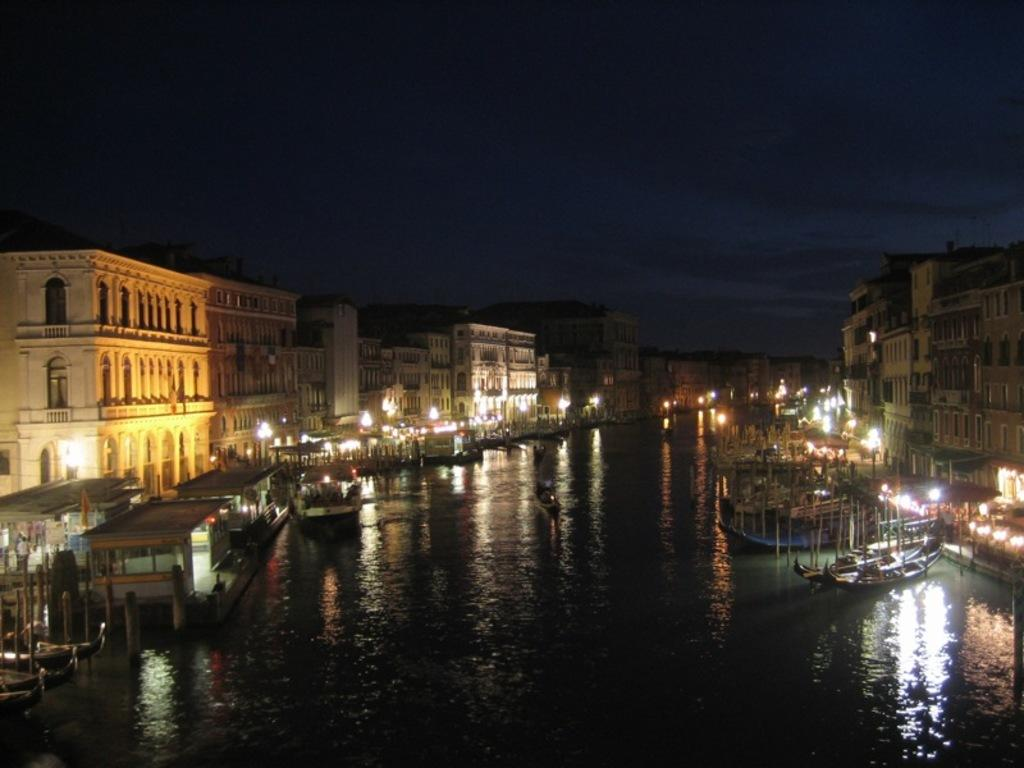What is the main feature in the center of the image? There is a canal in the center of the image. What is on the canal? There are boats on the canal. What can be seen in the background of the image? There are buildings and lights in the background of the image. What is visible in the sky in the image? The sky is visible in the background of the image. What type of sponge is being used to clean the boats in the image? There is no sponge present in the image, and no cleaning activity is depicted. 